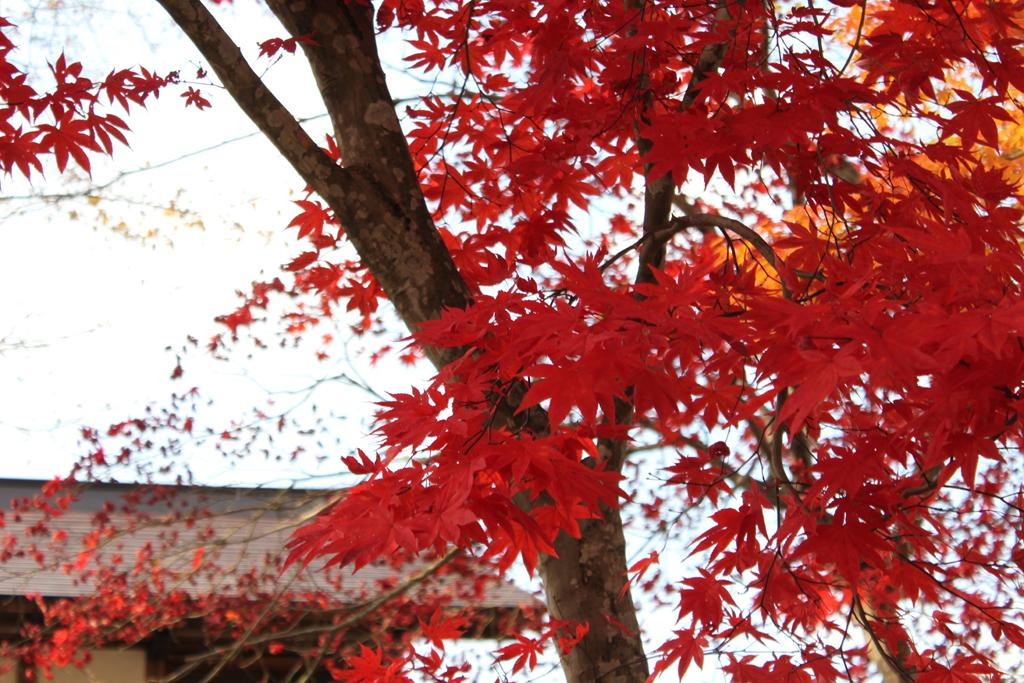What type of natural element is present in the image? There is a tree in the image. What can be seen in the background of the image? The sky is visible behind the tree. What type of man-made structure is present in the image? There is a building in the bottom left side of the image. Where is the hammer being used in the image? There is no hammer present in the image. What type of cork is visible in the image? There is no cork present in the image. 